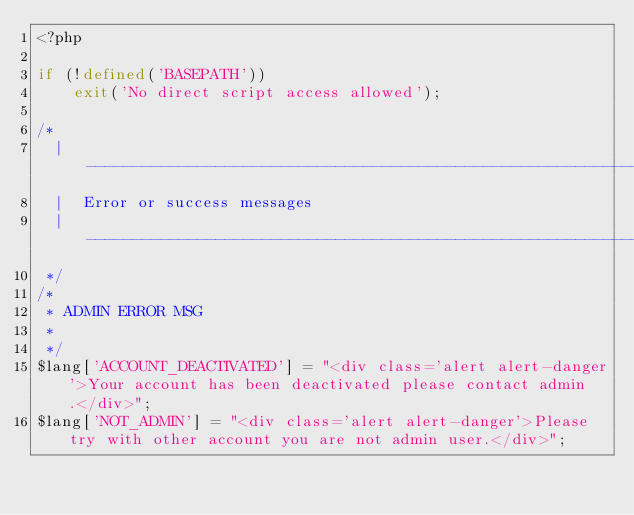<code> <loc_0><loc_0><loc_500><loc_500><_PHP_><?php

if (!defined('BASEPATH'))
    exit('No direct script access allowed');

/*
  | -------------------------------------------------------------------
  |  Error or success messages
  | -------------------------------------------------------------------
 */
/*
 * ADMIN ERROR MSG
 * 
 */
$lang['ACCOUNT_DEACTIVATED'] = "<div class='alert alert-danger'>Your account has been deactivated please contact admin.</div>";
$lang['NOT_ADMIN'] = "<div class='alert alert-danger'>Please try with other account you are not admin user.</div>";</code> 